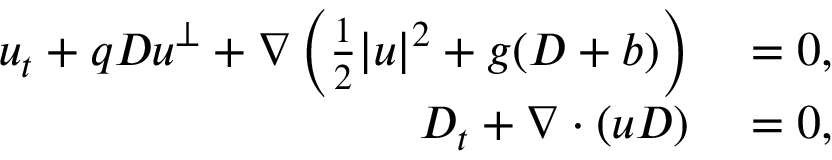Convert formula to latex. <formula><loc_0><loc_0><loc_500><loc_500>\begin{array} { r l } { u _ { t } + q D u ^ { \perp } + \nabla \left ( \frac { 1 } { 2 } | u | ^ { 2 } + g ( D + b ) \right ) } & = 0 , } \\ { D _ { t } + \nabla \cdot ( u D ) } & = 0 , } \end{array}</formula> 